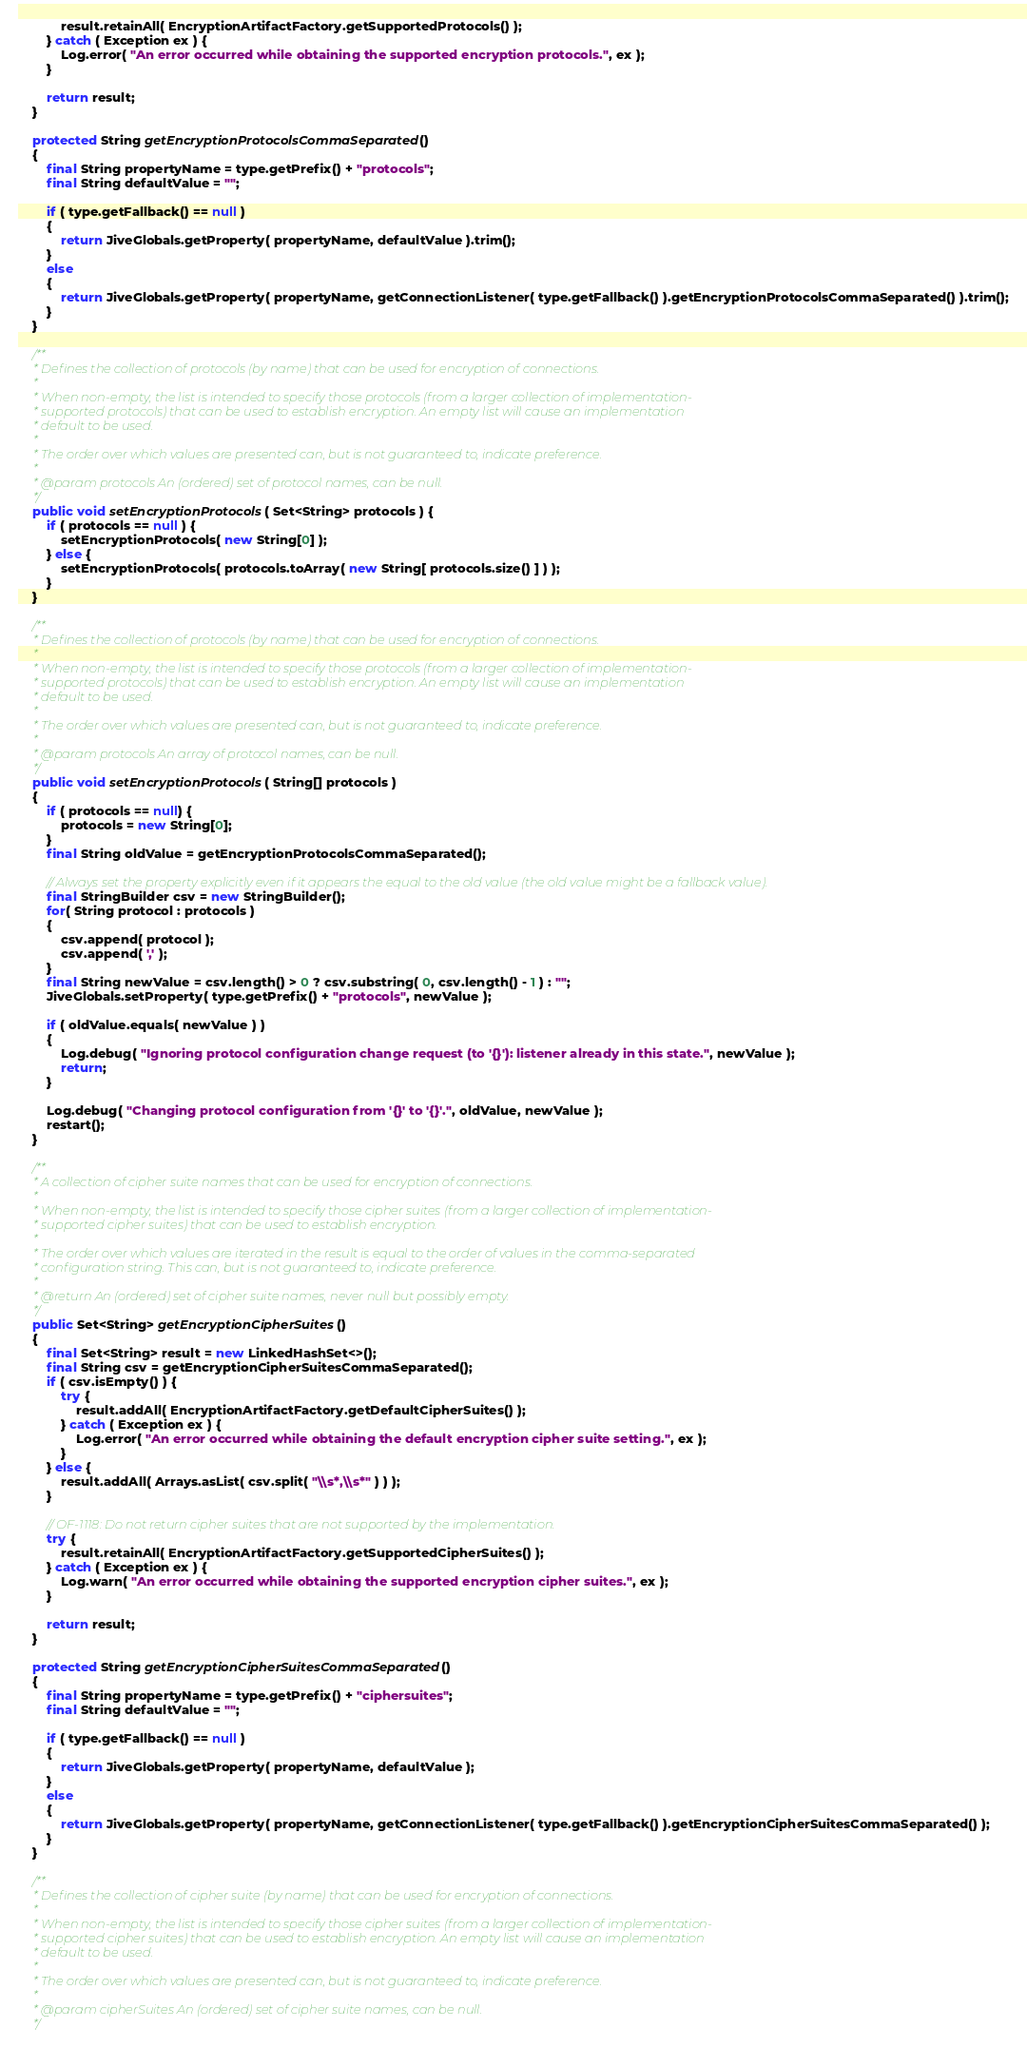<code> <loc_0><loc_0><loc_500><loc_500><_Java_>            result.retainAll( EncryptionArtifactFactory.getSupportedProtocols() );
        } catch ( Exception ex ) {
            Log.error( "An error occurred while obtaining the supported encryption protocols.", ex );
        }

        return result;
    }

    protected String getEncryptionProtocolsCommaSeparated()
    {
        final String propertyName = type.getPrefix() + "protocols";
        final String defaultValue = "";

        if ( type.getFallback() == null )
        {
            return JiveGlobals.getProperty( propertyName, defaultValue ).trim();
        }
        else
        {
            return JiveGlobals.getProperty( propertyName, getConnectionListener( type.getFallback() ).getEncryptionProtocolsCommaSeparated() ).trim();
        }
    }

    /**
     * Defines the collection of protocols (by name) that can be used for encryption of connections.
     *
     * When non-empty, the list is intended to specify those protocols (from a larger collection of implementation-
     * supported protocols) that can be used to establish encryption. An empty list will cause an implementation
     * default to be used.
     *
     * The order over which values are presented can, but is not guaranteed to, indicate preference.
     *
     * @param protocols An (ordered) set of protocol names, can be null.
     */
    public void setEncryptionProtocols( Set<String> protocols ) {
        if ( protocols == null ) {
            setEncryptionProtocols( new String[0] );
        } else {
            setEncryptionProtocols( protocols.toArray( new String[ protocols.size() ] ) );
        }
    }

    /**
     * Defines the collection of protocols (by name) that can be used for encryption of connections.
     *
     * When non-empty, the list is intended to specify those protocols (from a larger collection of implementation-
     * supported protocols) that can be used to establish encryption. An empty list will cause an implementation
     * default to be used.
     *
     * The order over which values are presented can, but is not guaranteed to, indicate preference.
     *
     * @param protocols An array of protocol names, can be null.
     */
    public void setEncryptionProtocols( String[] protocols )
    {
        if ( protocols == null) {
            protocols = new String[0];
        }
        final String oldValue = getEncryptionProtocolsCommaSeparated();

        // Always set the property explicitly even if it appears the equal to the old value (the old value might be a fallback value).
        final StringBuilder csv = new StringBuilder();
        for( String protocol : protocols )
        {
            csv.append( protocol );
            csv.append( ',' );
        }
        final String newValue = csv.length() > 0 ? csv.substring( 0, csv.length() - 1 ) : "";
        JiveGlobals.setProperty( type.getPrefix() + "protocols", newValue );

        if ( oldValue.equals( newValue ) )
        {
            Log.debug( "Ignoring protocol configuration change request (to '{}'): listener already in this state.", newValue );
            return;
        }

        Log.debug( "Changing protocol configuration from '{}' to '{}'.", oldValue, newValue );
        restart();
    }

    /**
     * A collection of cipher suite names that can be used for encryption of connections.
     *
     * When non-empty, the list is intended to specify those cipher suites (from a larger collection of implementation-
     * supported cipher suites) that can be used to establish encryption.
     *
     * The order over which values are iterated in the result is equal to the order of values in the comma-separated
     * configuration string. This can, but is not guaranteed to, indicate preference.
     *
     * @return An (ordered) set of cipher suite names, never null but possibly empty.
     */
    public Set<String> getEncryptionCipherSuites()
    {
        final Set<String> result = new LinkedHashSet<>();
        final String csv = getEncryptionCipherSuitesCommaSeparated();
        if ( csv.isEmpty() ) {
            try {
                result.addAll( EncryptionArtifactFactory.getDefaultCipherSuites() );
            } catch ( Exception ex ) {
                Log.error( "An error occurred while obtaining the default encryption cipher suite setting.", ex );
            }
        } else {
            result.addAll( Arrays.asList( csv.split( "\\s*,\\s*" ) ) );
        }

        // OF-1118: Do not return cipher suites that are not supported by the implementation.
        try {
            result.retainAll( EncryptionArtifactFactory.getSupportedCipherSuites() );
        } catch ( Exception ex ) {
            Log.warn( "An error occurred while obtaining the supported encryption cipher suites.", ex );
        }

        return result;
    }

    protected String getEncryptionCipherSuitesCommaSeparated()
    {
        final String propertyName = type.getPrefix() + "ciphersuites";
        final String defaultValue = "";

        if ( type.getFallback() == null )
        {
            return JiveGlobals.getProperty( propertyName, defaultValue );
        }
        else
        {
            return JiveGlobals.getProperty( propertyName, getConnectionListener( type.getFallback() ).getEncryptionCipherSuitesCommaSeparated() );
        }
    }

    /**
     * Defines the collection of cipher suite (by name) that can be used for encryption of connections.
     *
     * When non-empty, the list is intended to specify those cipher suites (from a larger collection of implementation-
     * supported cipher suites) that can be used to establish encryption. An empty list will cause an implementation
     * default to be used.
     *
     * The order over which values are presented can, but is not guaranteed to, indicate preference.
     *
     * @param cipherSuites An (ordered) set of cipher suite names, can be null.
     */</code> 